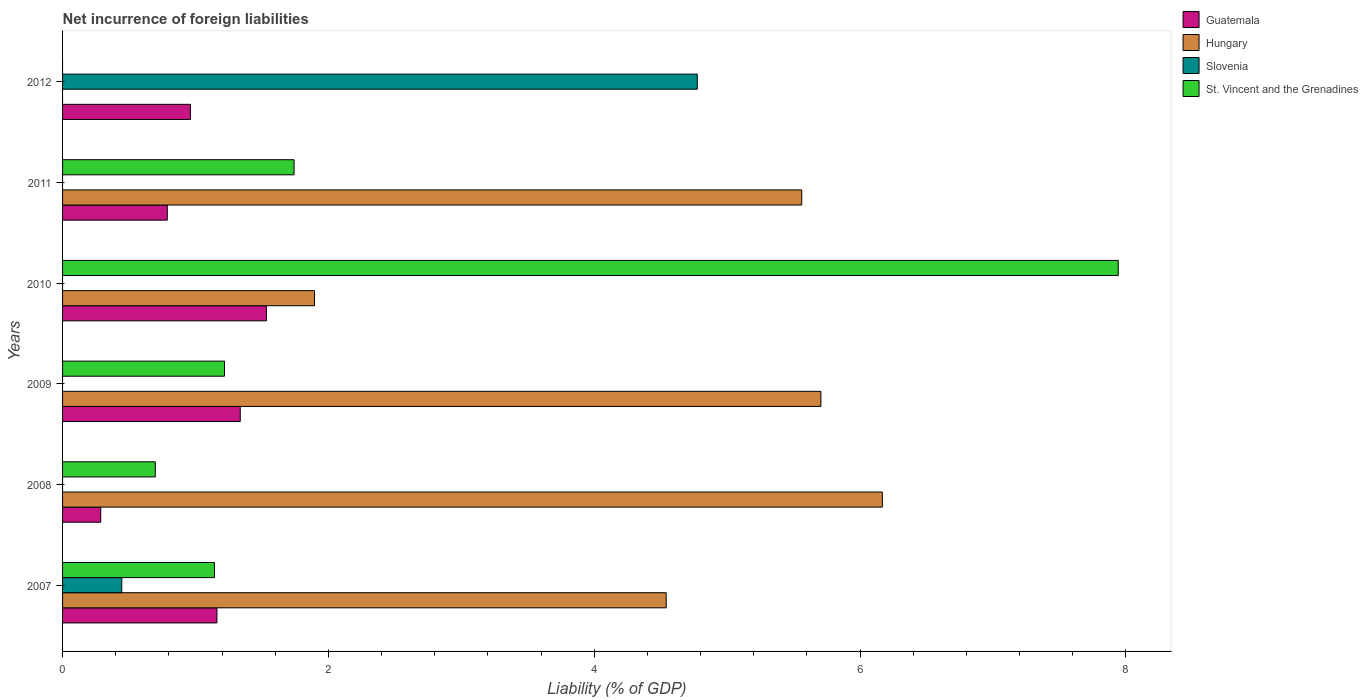How many groups of bars are there?
Ensure brevity in your answer.  6. Are the number of bars per tick equal to the number of legend labels?
Ensure brevity in your answer.  No. Are the number of bars on each tick of the Y-axis equal?
Keep it short and to the point. No. How many bars are there on the 4th tick from the bottom?
Ensure brevity in your answer.  3. What is the net incurrence of foreign liabilities in Guatemala in 2007?
Ensure brevity in your answer.  1.16. Across all years, what is the maximum net incurrence of foreign liabilities in St. Vincent and the Grenadines?
Provide a short and direct response. 7.94. Across all years, what is the minimum net incurrence of foreign liabilities in St. Vincent and the Grenadines?
Keep it short and to the point. 0. In which year was the net incurrence of foreign liabilities in Guatemala maximum?
Offer a very short reply. 2010. What is the total net incurrence of foreign liabilities in Hungary in the graph?
Your response must be concise. 23.87. What is the difference between the net incurrence of foreign liabilities in Guatemala in 2010 and that in 2012?
Your answer should be compact. 0.57. What is the difference between the net incurrence of foreign liabilities in Hungary in 2010 and the net incurrence of foreign liabilities in Guatemala in 2007?
Keep it short and to the point. 0.73. What is the average net incurrence of foreign liabilities in St. Vincent and the Grenadines per year?
Your response must be concise. 2.12. In the year 2008, what is the difference between the net incurrence of foreign liabilities in Guatemala and net incurrence of foreign liabilities in St. Vincent and the Grenadines?
Give a very brief answer. -0.41. In how many years, is the net incurrence of foreign liabilities in St. Vincent and the Grenadines greater than 6 %?
Provide a short and direct response. 1. What is the ratio of the net incurrence of foreign liabilities in Guatemala in 2007 to that in 2009?
Your answer should be compact. 0.87. What is the difference between the highest and the second highest net incurrence of foreign liabilities in Guatemala?
Provide a succinct answer. 0.2. What is the difference between the highest and the lowest net incurrence of foreign liabilities in Hungary?
Provide a succinct answer. 6.17. Is it the case that in every year, the sum of the net incurrence of foreign liabilities in St. Vincent and the Grenadines and net incurrence of foreign liabilities in Slovenia is greater than the sum of net incurrence of foreign liabilities in Guatemala and net incurrence of foreign liabilities in Hungary?
Offer a terse response. No. Are all the bars in the graph horizontal?
Make the answer very short. Yes. What is the difference between two consecutive major ticks on the X-axis?
Provide a short and direct response. 2. Does the graph contain any zero values?
Offer a very short reply. Yes. Does the graph contain grids?
Provide a succinct answer. No. Where does the legend appear in the graph?
Offer a very short reply. Top right. How many legend labels are there?
Your answer should be compact. 4. How are the legend labels stacked?
Your answer should be compact. Vertical. What is the title of the graph?
Provide a succinct answer. Net incurrence of foreign liabilities. Does "Lesotho" appear as one of the legend labels in the graph?
Offer a very short reply. No. What is the label or title of the X-axis?
Provide a succinct answer. Liability (% of GDP). What is the Liability (% of GDP) in Guatemala in 2007?
Offer a very short reply. 1.16. What is the Liability (% of GDP) of Hungary in 2007?
Make the answer very short. 4.54. What is the Liability (% of GDP) of Slovenia in 2007?
Your answer should be compact. 0.45. What is the Liability (% of GDP) in St. Vincent and the Grenadines in 2007?
Make the answer very short. 1.14. What is the Liability (% of GDP) of Guatemala in 2008?
Offer a very short reply. 0.29. What is the Liability (% of GDP) of Hungary in 2008?
Make the answer very short. 6.17. What is the Liability (% of GDP) of Slovenia in 2008?
Your answer should be compact. 0. What is the Liability (% of GDP) of St. Vincent and the Grenadines in 2008?
Provide a short and direct response. 0.7. What is the Liability (% of GDP) in Guatemala in 2009?
Make the answer very short. 1.34. What is the Liability (% of GDP) of Hungary in 2009?
Provide a succinct answer. 5.71. What is the Liability (% of GDP) in St. Vincent and the Grenadines in 2009?
Keep it short and to the point. 1.22. What is the Liability (% of GDP) in Guatemala in 2010?
Give a very brief answer. 1.53. What is the Liability (% of GDP) in Hungary in 2010?
Provide a short and direct response. 1.9. What is the Liability (% of GDP) in Slovenia in 2010?
Offer a terse response. 0. What is the Liability (% of GDP) of St. Vincent and the Grenadines in 2010?
Provide a succinct answer. 7.94. What is the Liability (% of GDP) of Guatemala in 2011?
Make the answer very short. 0.79. What is the Liability (% of GDP) of Hungary in 2011?
Offer a very short reply. 5.56. What is the Liability (% of GDP) of Slovenia in 2011?
Offer a terse response. 0. What is the Liability (% of GDP) in St. Vincent and the Grenadines in 2011?
Keep it short and to the point. 1.74. What is the Liability (% of GDP) in Guatemala in 2012?
Offer a terse response. 0.96. What is the Liability (% of GDP) in Slovenia in 2012?
Your answer should be compact. 4.78. Across all years, what is the maximum Liability (% of GDP) in Guatemala?
Your answer should be compact. 1.53. Across all years, what is the maximum Liability (% of GDP) in Hungary?
Your answer should be compact. 6.17. Across all years, what is the maximum Liability (% of GDP) of Slovenia?
Make the answer very short. 4.78. Across all years, what is the maximum Liability (% of GDP) of St. Vincent and the Grenadines?
Provide a short and direct response. 7.94. Across all years, what is the minimum Liability (% of GDP) in Guatemala?
Your answer should be very brief. 0.29. What is the total Liability (% of GDP) of Guatemala in the graph?
Keep it short and to the point. 6.07. What is the total Liability (% of GDP) in Hungary in the graph?
Keep it short and to the point. 23.87. What is the total Liability (% of GDP) in Slovenia in the graph?
Ensure brevity in your answer.  5.22. What is the total Liability (% of GDP) of St. Vincent and the Grenadines in the graph?
Your response must be concise. 12.74. What is the difference between the Liability (% of GDP) in Guatemala in 2007 and that in 2008?
Your answer should be very brief. 0.87. What is the difference between the Liability (% of GDP) in Hungary in 2007 and that in 2008?
Your answer should be very brief. -1.63. What is the difference between the Liability (% of GDP) of St. Vincent and the Grenadines in 2007 and that in 2008?
Give a very brief answer. 0.45. What is the difference between the Liability (% of GDP) of Guatemala in 2007 and that in 2009?
Keep it short and to the point. -0.18. What is the difference between the Liability (% of GDP) in Hungary in 2007 and that in 2009?
Provide a succinct answer. -1.16. What is the difference between the Liability (% of GDP) of St. Vincent and the Grenadines in 2007 and that in 2009?
Your answer should be compact. -0.08. What is the difference between the Liability (% of GDP) in Guatemala in 2007 and that in 2010?
Provide a short and direct response. -0.37. What is the difference between the Liability (% of GDP) in Hungary in 2007 and that in 2010?
Keep it short and to the point. 2.65. What is the difference between the Liability (% of GDP) in St. Vincent and the Grenadines in 2007 and that in 2010?
Offer a very short reply. -6.8. What is the difference between the Liability (% of GDP) in Guatemala in 2007 and that in 2011?
Keep it short and to the point. 0.37. What is the difference between the Liability (% of GDP) in Hungary in 2007 and that in 2011?
Ensure brevity in your answer.  -1.02. What is the difference between the Liability (% of GDP) of St. Vincent and the Grenadines in 2007 and that in 2011?
Offer a terse response. -0.6. What is the difference between the Liability (% of GDP) of Guatemala in 2007 and that in 2012?
Provide a succinct answer. 0.2. What is the difference between the Liability (% of GDP) in Slovenia in 2007 and that in 2012?
Offer a terse response. -4.33. What is the difference between the Liability (% of GDP) in Guatemala in 2008 and that in 2009?
Ensure brevity in your answer.  -1.05. What is the difference between the Liability (% of GDP) in Hungary in 2008 and that in 2009?
Your answer should be very brief. 0.46. What is the difference between the Liability (% of GDP) in St. Vincent and the Grenadines in 2008 and that in 2009?
Offer a terse response. -0.52. What is the difference between the Liability (% of GDP) of Guatemala in 2008 and that in 2010?
Give a very brief answer. -1.25. What is the difference between the Liability (% of GDP) in Hungary in 2008 and that in 2010?
Make the answer very short. 4.27. What is the difference between the Liability (% of GDP) in St. Vincent and the Grenadines in 2008 and that in 2010?
Provide a short and direct response. -7.25. What is the difference between the Liability (% of GDP) of Guatemala in 2008 and that in 2011?
Offer a terse response. -0.5. What is the difference between the Liability (% of GDP) of Hungary in 2008 and that in 2011?
Your response must be concise. 0.61. What is the difference between the Liability (% of GDP) of St. Vincent and the Grenadines in 2008 and that in 2011?
Your answer should be very brief. -1.04. What is the difference between the Liability (% of GDP) of Guatemala in 2008 and that in 2012?
Make the answer very short. -0.67. What is the difference between the Liability (% of GDP) in Guatemala in 2009 and that in 2010?
Provide a succinct answer. -0.2. What is the difference between the Liability (% of GDP) in Hungary in 2009 and that in 2010?
Make the answer very short. 3.81. What is the difference between the Liability (% of GDP) of St. Vincent and the Grenadines in 2009 and that in 2010?
Provide a short and direct response. -6.72. What is the difference between the Liability (% of GDP) of Guatemala in 2009 and that in 2011?
Give a very brief answer. 0.55. What is the difference between the Liability (% of GDP) in Hungary in 2009 and that in 2011?
Make the answer very short. 0.14. What is the difference between the Liability (% of GDP) in St. Vincent and the Grenadines in 2009 and that in 2011?
Your answer should be compact. -0.52. What is the difference between the Liability (% of GDP) of Guatemala in 2009 and that in 2012?
Keep it short and to the point. 0.37. What is the difference between the Liability (% of GDP) of Guatemala in 2010 and that in 2011?
Provide a succinct answer. 0.75. What is the difference between the Liability (% of GDP) of Hungary in 2010 and that in 2011?
Keep it short and to the point. -3.67. What is the difference between the Liability (% of GDP) of St. Vincent and the Grenadines in 2010 and that in 2011?
Your answer should be compact. 6.2. What is the difference between the Liability (% of GDP) in Guatemala in 2010 and that in 2012?
Provide a succinct answer. 0.57. What is the difference between the Liability (% of GDP) in Guatemala in 2011 and that in 2012?
Provide a succinct answer. -0.17. What is the difference between the Liability (% of GDP) in Guatemala in 2007 and the Liability (% of GDP) in Hungary in 2008?
Provide a succinct answer. -5.01. What is the difference between the Liability (% of GDP) of Guatemala in 2007 and the Liability (% of GDP) of St. Vincent and the Grenadines in 2008?
Your response must be concise. 0.46. What is the difference between the Liability (% of GDP) in Hungary in 2007 and the Liability (% of GDP) in St. Vincent and the Grenadines in 2008?
Keep it short and to the point. 3.84. What is the difference between the Liability (% of GDP) in Slovenia in 2007 and the Liability (% of GDP) in St. Vincent and the Grenadines in 2008?
Offer a terse response. -0.25. What is the difference between the Liability (% of GDP) of Guatemala in 2007 and the Liability (% of GDP) of Hungary in 2009?
Your answer should be very brief. -4.54. What is the difference between the Liability (% of GDP) in Guatemala in 2007 and the Liability (% of GDP) in St. Vincent and the Grenadines in 2009?
Ensure brevity in your answer.  -0.06. What is the difference between the Liability (% of GDP) of Hungary in 2007 and the Liability (% of GDP) of St. Vincent and the Grenadines in 2009?
Give a very brief answer. 3.32. What is the difference between the Liability (% of GDP) of Slovenia in 2007 and the Liability (% of GDP) of St. Vincent and the Grenadines in 2009?
Provide a succinct answer. -0.77. What is the difference between the Liability (% of GDP) in Guatemala in 2007 and the Liability (% of GDP) in Hungary in 2010?
Your answer should be compact. -0.73. What is the difference between the Liability (% of GDP) in Guatemala in 2007 and the Liability (% of GDP) in St. Vincent and the Grenadines in 2010?
Your answer should be very brief. -6.78. What is the difference between the Liability (% of GDP) of Hungary in 2007 and the Liability (% of GDP) of St. Vincent and the Grenadines in 2010?
Your response must be concise. -3.4. What is the difference between the Liability (% of GDP) in Slovenia in 2007 and the Liability (% of GDP) in St. Vincent and the Grenadines in 2010?
Make the answer very short. -7.5. What is the difference between the Liability (% of GDP) in Guatemala in 2007 and the Liability (% of GDP) in Hungary in 2011?
Give a very brief answer. -4.4. What is the difference between the Liability (% of GDP) in Guatemala in 2007 and the Liability (% of GDP) in St. Vincent and the Grenadines in 2011?
Your response must be concise. -0.58. What is the difference between the Liability (% of GDP) in Hungary in 2007 and the Liability (% of GDP) in St. Vincent and the Grenadines in 2011?
Make the answer very short. 2.8. What is the difference between the Liability (% of GDP) of Slovenia in 2007 and the Liability (% of GDP) of St. Vincent and the Grenadines in 2011?
Provide a short and direct response. -1.3. What is the difference between the Liability (% of GDP) of Guatemala in 2007 and the Liability (% of GDP) of Slovenia in 2012?
Keep it short and to the point. -3.61. What is the difference between the Liability (% of GDP) of Hungary in 2007 and the Liability (% of GDP) of Slovenia in 2012?
Keep it short and to the point. -0.23. What is the difference between the Liability (% of GDP) in Guatemala in 2008 and the Liability (% of GDP) in Hungary in 2009?
Keep it short and to the point. -5.42. What is the difference between the Liability (% of GDP) of Guatemala in 2008 and the Liability (% of GDP) of St. Vincent and the Grenadines in 2009?
Your response must be concise. -0.93. What is the difference between the Liability (% of GDP) in Hungary in 2008 and the Liability (% of GDP) in St. Vincent and the Grenadines in 2009?
Make the answer very short. 4.95. What is the difference between the Liability (% of GDP) in Guatemala in 2008 and the Liability (% of GDP) in Hungary in 2010?
Your answer should be compact. -1.61. What is the difference between the Liability (% of GDP) of Guatemala in 2008 and the Liability (% of GDP) of St. Vincent and the Grenadines in 2010?
Provide a short and direct response. -7.66. What is the difference between the Liability (% of GDP) in Hungary in 2008 and the Liability (% of GDP) in St. Vincent and the Grenadines in 2010?
Offer a terse response. -1.78. What is the difference between the Liability (% of GDP) of Guatemala in 2008 and the Liability (% of GDP) of Hungary in 2011?
Your response must be concise. -5.27. What is the difference between the Liability (% of GDP) in Guatemala in 2008 and the Liability (% of GDP) in St. Vincent and the Grenadines in 2011?
Provide a short and direct response. -1.45. What is the difference between the Liability (% of GDP) of Hungary in 2008 and the Liability (% of GDP) of St. Vincent and the Grenadines in 2011?
Ensure brevity in your answer.  4.43. What is the difference between the Liability (% of GDP) of Guatemala in 2008 and the Liability (% of GDP) of Slovenia in 2012?
Your answer should be very brief. -4.49. What is the difference between the Liability (% of GDP) of Hungary in 2008 and the Liability (% of GDP) of Slovenia in 2012?
Offer a terse response. 1.39. What is the difference between the Liability (% of GDP) in Guatemala in 2009 and the Liability (% of GDP) in Hungary in 2010?
Make the answer very short. -0.56. What is the difference between the Liability (% of GDP) in Guatemala in 2009 and the Liability (% of GDP) in St. Vincent and the Grenadines in 2010?
Your answer should be very brief. -6.61. What is the difference between the Liability (% of GDP) in Hungary in 2009 and the Liability (% of GDP) in St. Vincent and the Grenadines in 2010?
Provide a succinct answer. -2.24. What is the difference between the Liability (% of GDP) in Guatemala in 2009 and the Liability (% of GDP) in Hungary in 2011?
Make the answer very short. -4.22. What is the difference between the Liability (% of GDP) of Guatemala in 2009 and the Liability (% of GDP) of St. Vincent and the Grenadines in 2011?
Provide a succinct answer. -0.41. What is the difference between the Liability (% of GDP) of Hungary in 2009 and the Liability (% of GDP) of St. Vincent and the Grenadines in 2011?
Provide a succinct answer. 3.96. What is the difference between the Liability (% of GDP) in Guatemala in 2009 and the Liability (% of GDP) in Slovenia in 2012?
Provide a succinct answer. -3.44. What is the difference between the Liability (% of GDP) of Hungary in 2009 and the Liability (% of GDP) of Slovenia in 2012?
Provide a succinct answer. 0.93. What is the difference between the Liability (% of GDP) in Guatemala in 2010 and the Liability (% of GDP) in Hungary in 2011?
Make the answer very short. -4.03. What is the difference between the Liability (% of GDP) of Guatemala in 2010 and the Liability (% of GDP) of St. Vincent and the Grenadines in 2011?
Offer a very short reply. -0.21. What is the difference between the Liability (% of GDP) of Hungary in 2010 and the Liability (% of GDP) of St. Vincent and the Grenadines in 2011?
Your answer should be compact. 0.15. What is the difference between the Liability (% of GDP) of Guatemala in 2010 and the Liability (% of GDP) of Slovenia in 2012?
Your answer should be compact. -3.24. What is the difference between the Liability (% of GDP) in Hungary in 2010 and the Liability (% of GDP) in Slovenia in 2012?
Give a very brief answer. -2.88. What is the difference between the Liability (% of GDP) of Guatemala in 2011 and the Liability (% of GDP) of Slovenia in 2012?
Keep it short and to the point. -3.99. What is the difference between the Liability (% of GDP) in Hungary in 2011 and the Liability (% of GDP) in Slovenia in 2012?
Your response must be concise. 0.79. What is the average Liability (% of GDP) of Guatemala per year?
Give a very brief answer. 1.01. What is the average Liability (% of GDP) in Hungary per year?
Your response must be concise. 3.98. What is the average Liability (% of GDP) of Slovenia per year?
Make the answer very short. 0.87. What is the average Liability (% of GDP) of St. Vincent and the Grenadines per year?
Your answer should be compact. 2.12. In the year 2007, what is the difference between the Liability (% of GDP) of Guatemala and Liability (% of GDP) of Hungary?
Offer a terse response. -3.38. In the year 2007, what is the difference between the Liability (% of GDP) in Guatemala and Liability (% of GDP) in Slovenia?
Give a very brief answer. 0.72. In the year 2007, what is the difference between the Liability (% of GDP) in Guatemala and Liability (% of GDP) in St. Vincent and the Grenadines?
Offer a terse response. 0.02. In the year 2007, what is the difference between the Liability (% of GDP) in Hungary and Liability (% of GDP) in Slovenia?
Provide a short and direct response. 4.1. In the year 2007, what is the difference between the Liability (% of GDP) in Hungary and Liability (% of GDP) in St. Vincent and the Grenadines?
Provide a short and direct response. 3.4. In the year 2007, what is the difference between the Liability (% of GDP) of Slovenia and Liability (% of GDP) of St. Vincent and the Grenadines?
Offer a terse response. -0.7. In the year 2008, what is the difference between the Liability (% of GDP) in Guatemala and Liability (% of GDP) in Hungary?
Offer a very short reply. -5.88. In the year 2008, what is the difference between the Liability (% of GDP) of Guatemala and Liability (% of GDP) of St. Vincent and the Grenadines?
Make the answer very short. -0.41. In the year 2008, what is the difference between the Liability (% of GDP) of Hungary and Liability (% of GDP) of St. Vincent and the Grenadines?
Your response must be concise. 5.47. In the year 2009, what is the difference between the Liability (% of GDP) in Guatemala and Liability (% of GDP) in Hungary?
Provide a short and direct response. -4.37. In the year 2009, what is the difference between the Liability (% of GDP) in Guatemala and Liability (% of GDP) in St. Vincent and the Grenadines?
Ensure brevity in your answer.  0.12. In the year 2009, what is the difference between the Liability (% of GDP) in Hungary and Liability (% of GDP) in St. Vincent and the Grenadines?
Keep it short and to the point. 4.49. In the year 2010, what is the difference between the Liability (% of GDP) in Guatemala and Liability (% of GDP) in Hungary?
Your answer should be compact. -0.36. In the year 2010, what is the difference between the Liability (% of GDP) in Guatemala and Liability (% of GDP) in St. Vincent and the Grenadines?
Your answer should be compact. -6.41. In the year 2010, what is the difference between the Liability (% of GDP) of Hungary and Liability (% of GDP) of St. Vincent and the Grenadines?
Make the answer very short. -6.05. In the year 2011, what is the difference between the Liability (% of GDP) in Guatemala and Liability (% of GDP) in Hungary?
Offer a very short reply. -4.77. In the year 2011, what is the difference between the Liability (% of GDP) in Guatemala and Liability (% of GDP) in St. Vincent and the Grenadines?
Make the answer very short. -0.95. In the year 2011, what is the difference between the Liability (% of GDP) in Hungary and Liability (% of GDP) in St. Vincent and the Grenadines?
Make the answer very short. 3.82. In the year 2012, what is the difference between the Liability (% of GDP) of Guatemala and Liability (% of GDP) of Slovenia?
Give a very brief answer. -3.81. What is the ratio of the Liability (% of GDP) of Guatemala in 2007 to that in 2008?
Your answer should be compact. 4.04. What is the ratio of the Liability (% of GDP) in Hungary in 2007 to that in 2008?
Keep it short and to the point. 0.74. What is the ratio of the Liability (% of GDP) in St. Vincent and the Grenadines in 2007 to that in 2008?
Offer a very short reply. 1.64. What is the ratio of the Liability (% of GDP) of Guatemala in 2007 to that in 2009?
Offer a terse response. 0.87. What is the ratio of the Liability (% of GDP) of Hungary in 2007 to that in 2009?
Give a very brief answer. 0.8. What is the ratio of the Liability (% of GDP) in St. Vincent and the Grenadines in 2007 to that in 2009?
Give a very brief answer. 0.94. What is the ratio of the Liability (% of GDP) in Guatemala in 2007 to that in 2010?
Give a very brief answer. 0.76. What is the ratio of the Liability (% of GDP) in Hungary in 2007 to that in 2010?
Give a very brief answer. 2.4. What is the ratio of the Liability (% of GDP) in St. Vincent and the Grenadines in 2007 to that in 2010?
Give a very brief answer. 0.14. What is the ratio of the Liability (% of GDP) in Guatemala in 2007 to that in 2011?
Offer a terse response. 1.47. What is the ratio of the Liability (% of GDP) in Hungary in 2007 to that in 2011?
Provide a short and direct response. 0.82. What is the ratio of the Liability (% of GDP) of St. Vincent and the Grenadines in 2007 to that in 2011?
Offer a terse response. 0.66. What is the ratio of the Liability (% of GDP) in Guatemala in 2007 to that in 2012?
Ensure brevity in your answer.  1.21. What is the ratio of the Liability (% of GDP) of Slovenia in 2007 to that in 2012?
Provide a succinct answer. 0.09. What is the ratio of the Liability (% of GDP) of Guatemala in 2008 to that in 2009?
Keep it short and to the point. 0.21. What is the ratio of the Liability (% of GDP) in Hungary in 2008 to that in 2009?
Provide a succinct answer. 1.08. What is the ratio of the Liability (% of GDP) of St. Vincent and the Grenadines in 2008 to that in 2009?
Your answer should be compact. 0.57. What is the ratio of the Liability (% of GDP) in Guatemala in 2008 to that in 2010?
Your response must be concise. 0.19. What is the ratio of the Liability (% of GDP) in Hungary in 2008 to that in 2010?
Offer a very short reply. 3.25. What is the ratio of the Liability (% of GDP) in St. Vincent and the Grenadines in 2008 to that in 2010?
Your response must be concise. 0.09. What is the ratio of the Liability (% of GDP) in Guatemala in 2008 to that in 2011?
Keep it short and to the point. 0.36. What is the ratio of the Liability (% of GDP) of Hungary in 2008 to that in 2011?
Ensure brevity in your answer.  1.11. What is the ratio of the Liability (% of GDP) in St. Vincent and the Grenadines in 2008 to that in 2011?
Provide a short and direct response. 0.4. What is the ratio of the Liability (% of GDP) of Guatemala in 2008 to that in 2012?
Provide a short and direct response. 0.3. What is the ratio of the Liability (% of GDP) in Guatemala in 2009 to that in 2010?
Keep it short and to the point. 0.87. What is the ratio of the Liability (% of GDP) of Hungary in 2009 to that in 2010?
Make the answer very short. 3.01. What is the ratio of the Liability (% of GDP) of St. Vincent and the Grenadines in 2009 to that in 2010?
Offer a terse response. 0.15. What is the ratio of the Liability (% of GDP) in Guatemala in 2009 to that in 2011?
Make the answer very short. 1.7. What is the ratio of the Liability (% of GDP) of Hungary in 2009 to that in 2011?
Provide a short and direct response. 1.03. What is the ratio of the Liability (% of GDP) in St. Vincent and the Grenadines in 2009 to that in 2011?
Ensure brevity in your answer.  0.7. What is the ratio of the Liability (% of GDP) of Guatemala in 2009 to that in 2012?
Keep it short and to the point. 1.39. What is the ratio of the Liability (% of GDP) of Guatemala in 2010 to that in 2011?
Your answer should be very brief. 1.95. What is the ratio of the Liability (% of GDP) of Hungary in 2010 to that in 2011?
Your answer should be compact. 0.34. What is the ratio of the Liability (% of GDP) of St. Vincent and the Grenadines in 2010 to that in 2011?
Make the answer very short. 4.56. What is the ratio of the Liability (% of GDP) in Guatemala in 2010 to that in 2012?
Your answer should be very brief. 1.59. What is the ratio of the Liability (% of GDP) of Guatemala in 2011 to that in 2012?
Give a very brief answer. 0.82. What is the difference between the highest and the second highest Liability (% of GDP) in Guatemala?
Provide a succinct answer. 0.2. What is the difference between the highest and the second highest Liability (% of GDP) of Hungary?
Your response must be concise. 0.46. What is the difference between the highest and the second highest Liability (% of GDP) of St. Vincent and the Grenadines?
Your answer should be compact. 6.2. What is the difference between the highest and the lowest Liability (% of GDP) in Guatemala?
Provide a short and direct response. 1.25. What is the difference between the highest and the lowest Liability (% of GDP) of Hungary?
Offer a very short reply. 6.17. What is the difference between the highest and the lowest Liability (% of GDP) in Slovenia?
Offer a very short reply. 4.78. What is the difference between the highest and the lowest Liability (% of GDP) of St. Vincent and the Grenadines?
Offer a terse response. 7.94. 